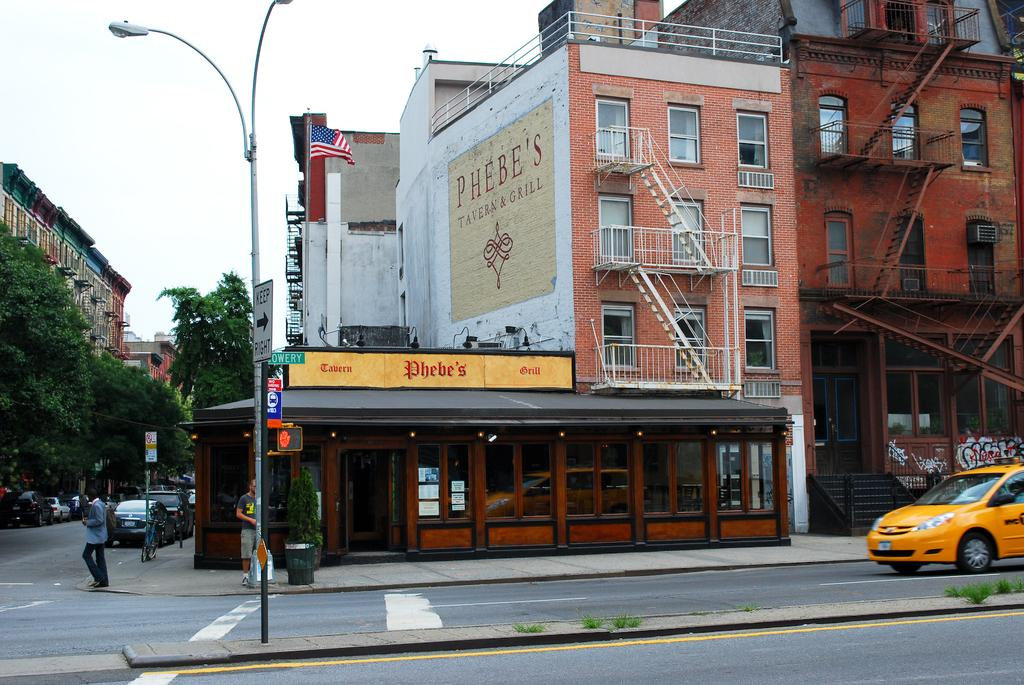<image>
Provide a brief description of the given image. Phebe's Tavern & Grill has a huge painted sign on the brick wall above the restaurant. 